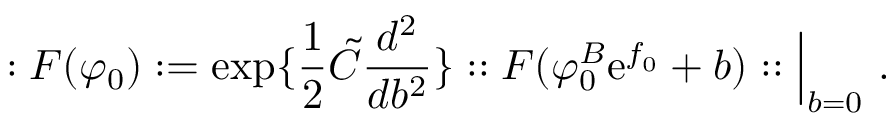<formula> <loc_0><loc_0><loc_500><loc_500>\colon F ( \varphi _ { 0 } ) \colon = \exp \{ { \frac { 1 } { 2 } } \tilde { C } { \frac { d ^ { 2 } } { d b ^ { 2 } } } \} \colon \colon F ( \varphi _ { 0 } ^ { B } e ^ { f _ { 0 } } + b ) \colon \colon \Big | _ { b = 0 } .</formula> 